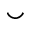<formula> <loc_0><loc_0><loc_500><loc_500>\smile</formula> 